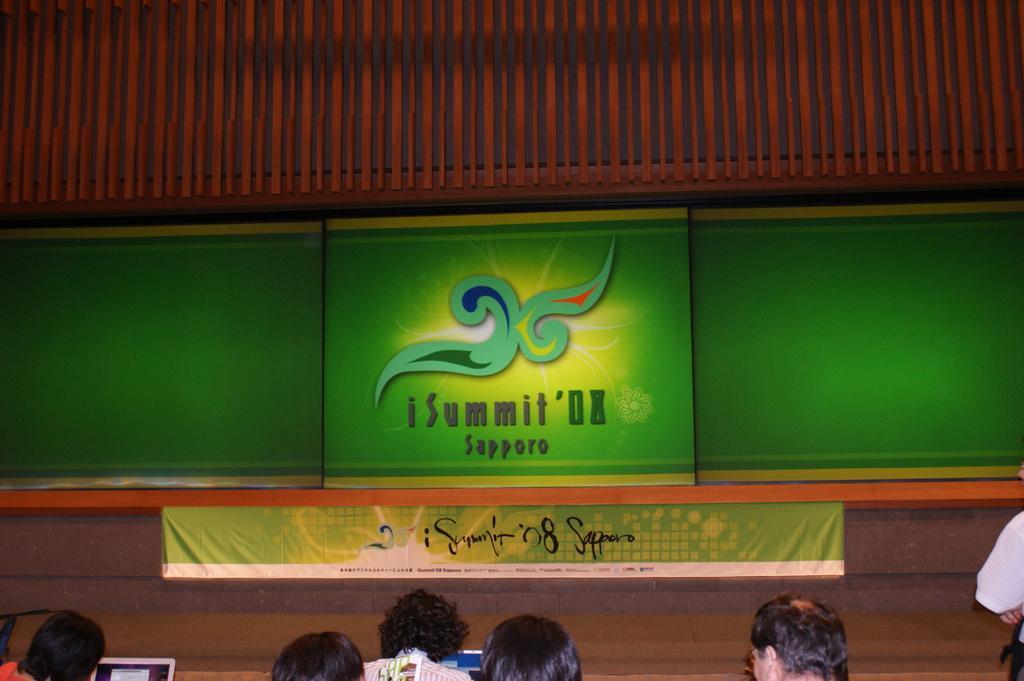How would you summarize this image in a sentence or two? In the center of the image, we can see screens and there is a banner. At the bottom, there are some people and we can see laptops. At the top, there is roof. 